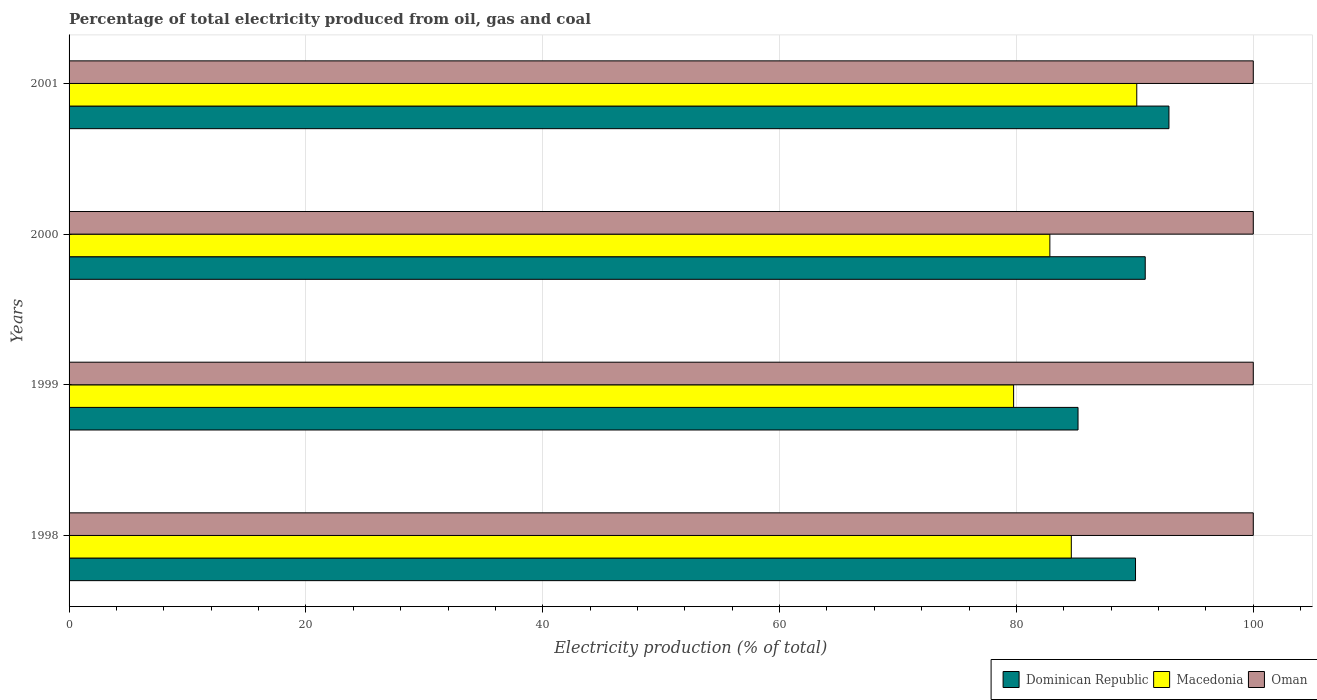Are the number of bars per tick equal to the number of legend labels?
Your answer should be compact. Yes. How many bars are there on the 2nd tick from the top?
Give a very brief answer. 3. How many bars are there on the 1st tick from the bottom?
Provide a succinct answer. 3. In how many cases, is the number of bars for a given year not equal to the number of legend labels?
Provide a short and direct response. 0. Across all years, what is the maximum electricity production in in Macedonia?
Offer a very short reply. 90.16. Across all years, what is the minimum electricity production in in Macedonia?
Your answer should be very brief. 79.76. What is the difference between the electricity production in in Dominican Republic in 1999 and that in 2000?
Provide a short and direct response. -5.68. What is the difference between the electricity production in in Dominican Republic in 2000 and the electricity production in in Macedonia in 1998?
Give a very brief answer. 6.24. What is the average electricity production in in Dominican Republic per year?
Give a very brief answer. 89.75. In the year 1999, what is the difference between the electricity production in in Dominican Republic and electricity production in in Macedonia?
Your answer should be compact. 5.44. What is the ratio of the electricity production in in Macedonia in 1998 to that in 1999?
Provide a succinct answer. 1.06. Is the difference between the electricity production in in Dominican Republic in 2000 and 2001 greater than the difference between the electricity production in in Macedonia in 2000 and 2001?
Offer a very short reply. Yes. What is the difference between the highest and the second highest electricity production in in Dominican Republic?
Your response must be concise. 2. What is the difference between the highest and the lowest electricity production in in Macedonia?
Keep it short and to the point. 10.4. Is the sum of the electricity production in in Macedonia in 1998 and 2001 greater than the maximum electricity production in in Dominican Republic across all years?
Ensure brevity in your answer.  Yes. What does the 1st bar from the top in 1999 represents?
Give a very brief answer. Oman. What does the 1st bar from the bottom in 1998 represents?
Your answer should be compact. Dominican Republic. Is it the case that in every year, the sum of the electricity production in in Dominican Republic and electricity production in in Macedonia is greater than the electricity production in in Oman?
Your answer should be compact. Yes. Are all the bars in the graph horizontal?
Give a very brief answer. Yes. What is the difference between two consecutive major ticks on the X-axis?
Provide a succinct answer. 20. Are the values on the major ticks of X-axis written in scientific E-notation?
Keep it short and to the point. No. How are the legend labels stacked?
Provide a succinct answer. Horizontal. What is the title of the graph?
Offer a terse response. Percentage of total electricity produced from oil, gas and coal. What is the label or title of the X-axis?
Provide a succinct answer. Electricity production (% of total). What is the Electricity production (% of total) of Dominican Republic in 1998?
Keep it short and to the point. 90.06. What is the Electricity production (% of total) in Macedonia in 1998?
Your answer should be compact. 84.63. What is the Electricity production (% of total) of Dominican Republic in 1999?
Your answer should be compact. 85.2. What is the Electricity production (% of total) in Macedonia in 1999?
Provide a short and direct response. 79.76. What is the Electricity production (% of total) of Oman in 1999?
Your response must be concise. 100. What is the Electricity production (% of total) of Dominican Republic in 2000?
Your answer should be very brief. 90.88. What is the Electricity production (% of total) of Macedonia in 2000?
Ensure brevity in your answer.  82.82. What is the Electricity production (% of total) of Dominican Republic in 2001?
Make the answer very short. 92.88. What is the Electricity production (% of total) in Macedonia in 2001?
Your answer should be very brief. 90.16. What is the Electricity production (% of total) of Oman in 2001?
Keep it short and to the point. 100. Across all years, what is the maximum Electricity production (% of total) of Dominican Republic?
Your answer should be very brief. 92.88. Across all years, what is the maximum Electricity production (% of total) of Macedonia?
Provide a short and direct response. 90.16. Across all years, what is the minimum Electricity production (% of total) in Dominican Republic?
Give a very brief answer. 85.2. Across all years, what is the minimum Electricity production (% of total) in Macedonia?
Your answer should be compact. 79.76. Across all years, what is the minimum Electricity production (% of total) in Oman?
Provide a succinct answer. 100. What is the total Electricity production (% of total) in Dominican Republic in the graph?
Keep it short and to the point. 359.01. What is the total Electricity production (% of total) of Macedonia in the graph?
Your response must be concise. 337.38. What is the total Electricity production (% of total) in Oman in the graph?
Ensure brevity in your answer.  400. What is the difference between the Electricity production (% of total) of Dominican Republic in 1998 and that in 1999?
Make the answer very short. 4.86. What is the difference between the Electricity production (% of total) in Macedonia in 1998 and that in 1999?
Offer a terse response. 4.87. What is the difference between the Electricity production (% of total) of Oman in 1998 and that in 1999?
Your answer should be compact. 0. What is the difference between the Electricity production (% of total) in Dominican Republic in 1998 and that in 2000?
Offer a terse response. -0.82. What is the difference between the Electricity production (% of total) of Macedonia in 1998 and that in 2000?
Ensure brevity in your answer.  1.81. What is the difference between the Electricity production (% of total) in Oman in 1998 and that in 2000?
Your answer should be very brief. 0. What is the difference between the Electricity production (% of total) in Dominican Republic in 1998 and that in 2001?
Give a very brief answer. -2.82. What is the difference between the Electricity production (% of total) in Macedonia in 1998 and that in 2001?
Offer a terse response. -5.53. What is the difference between the Electricity production (% of total) of Dominican Republic in 1999 and that in 2000?
Give a very brief answer. -5.68. What is the difference between the Electricity production (% of total) in Macedonia in 1999 and that in 2000?
Your response must be concise. -3.06. What is the difference between the Electricity production (% of total) in Oman in 1999 and that in 2000?
Ensure brevity in your answer.  0. What is the difference between the Electricity production (% of total) of Dominican Republic in 1999 and that in 2001?
Give a very brief answer. -7.68. What is the difference between the Electricity production (% of total) in Macedonia in 1999 and that in 2001?
Offer a terse response. -10.4. What is the difference between the Electricity production (% of total) in Oman in 1999 and that in 2001?
Provide a succinct answer. 0. What is the difference between the Electricity production (% of total) in Dominican Republic in 2000 and that in 2001?
Your answer should be compact. -2. What is the difference between the Electricity production (% of total) of Macedonia in 2000 and that in 2001?
Provide a short and direct response. -7.34. What is the difference between the Electricity production (% of total) in Dominican Republic in 1998 and the Electricity production (% of total) in Macedonia in 1999?
Make the answer very short. 10.29. What is the difference between the Electricity production (% of total) in Dominican Republic in 1998 and the Electricity production (% of total) in Oman in 1999?
Give a very brief answer. -9.94. What is the difference between the Electricity production (% of total) in Macedonia in 1998 and the Electricity production (% of total) in Oman in 1999?
Your response must be concise. -15.37. What is the difference between the Electricity production (% of total) of Dominican Republic in 1998 and the Electricity production (% of total) of Macedonia in 2000?
Offer a terse response. 7.23. What is the difference between the Electricity production (% of total) of Dominican Republic in 1998 and the Electricity production (% of total) of Oman in 2000?
Offer a terse response. -9.94. What is the difference between the Electricity production (% of total) of Macedonia in 1998 and the Electricity production (% of total) of Oman in 2000?
Offer a very short reply. -15.37. What is the difference between the Electricity production (% of total) of Dominican Republic in 1998 and the Electricity production (% of total) of Macedonia in 2001?
Your answer should be very brief. -0.1. What is the difference between the Electricity production (% of total) in Dominican Republic in 1998 and the Electricity production (% of total) in Oman in 2001?
Give a very brief answer. -9.94. What is the difference between the Electricity production (% of total) of Macedonia in 1998 and the Electricity production (% of total) of Oman in 2001?
Ensure brevity in your answer.  -15.37. What is the difference between the Electricity production (% of total) of Dominican Republic in 1999 and the Electricity production (% of total) of Macedonia in 2000?
Your answer should be very brief. 2.38. What is the difference between the Electricity production (% of total) of Dominican Republic in 1999 and the Electricity production (% of total) of Oman in 2000?
Your answer should be compact. -14.8. What is the difference between the Electricity production (% of total) in Macedonia in 1999 and the Electricity production (% of total) in Oman in 2000?
Provide a short and direct response. -20.24. What is the difference between the Electricity production (% of total) in Dominican Republic in 1999 and the Electricity production (% of total) in Macedonia in 2001?
Provide a succinct answer. -4.96. What is the difference between the Electricity production (% of total) of Dominican Republic in 1999 and the Electricity production (% of total) of Oman in 2001?
Ensure brevity in your answer.  -14.8. What is the difference between the Electricity production (% of total) of Macedonia in 1999 and the Electricity production (% of total) of Oman in 2001?
Your response must be concise. -20.24. What is the difference between the Electricity production (% of total) of Dominican Republic in 2000 and the Electricity production (% of total) of Macedonia in 2001?
Ensure brevity in your answer.  0.72. What is the difference between the Electricity production (% of total) in Dominican Republic in 2000 and the Electricity production (% of total) in Oman in 2001?
Keep it short and to the point. -9.12. What is the difference between the Electricity production (% of total) in Macedonia in 2000 and the Electricity production (% of total) in Oman in 2001?
Offer a very short reply. -17.18. What is the average Electricity production (% of total) in Dominican Republic per year?
Provide a succinct answer. 89.75. What is the average Electricity production (% of total) of Macedonia per year?
Offer a very short reply. 84.34. What is the average Electricity production (% of total) of Oman per year?
Offer a very short reply. 100. In the year 1998, what is the difference between the Electricity production (% of total) of Dominican Republic and Electricity production (% of total) of Macedonia?
Give a very brief answer. 5.42. In the year 1998, what is the difference between the Electricity production (% of total) of Dominican Republic and Electricity production (% of total) of Oman?
Give a very brief answer. -9.94. In the year 1998, what is the difference between the Electricity production (% of total) of Macedonia and Electricity production (% of total) of Oman?
Offer a very short reply. -15.37. In the year 1999, what is the difference between the Electricity production (% of total) of Dominican Republic and Electricity production (% of total) of Macedonia?
Provide a succinct answer. 5.44. In the year 1999, what is the difference between the Electricity production (% of total) in Dominican Republic and Electricity production (% of total) in Oman?
Provide a short and direct response. -14.8. In the year 1999, what is the difference between the Electricity production (% of total) in Macedonia and Electricity production (% of total) in Oman?
Offer a very short reply. -20.24. In the year 2000, what is the difference between the Electricity production (% of total) of Dominican Republic and Electricity production (% of total) of Macedonia?
Make the answer very short. 8.05. In the year 2000, what is the difference between the Electricity production (% of total) of Dominican Republic and Electricity production (% of total) of Oman?
Provide a short and direct response. -9.12. In the year 2000, what is the difference between the Electricity production (% of total) in Macedonia and Electricity production (% of total) in Oman?
Your answer should be very brief. -17.18. In the year 2001, what is the difference between the Electricity production (% of total) in Dominican Republic and Electricity production (% of total) in Macedonia?
Your answer should be compact. 2.72. In the year 2001, what is the difference between the Electricity production (% of total) in Dominican Republic and Electricity production (% of total) in Oman?
Offer a very short reply. -7.12. In the year 2001, what is the difference between the Electricity production (% of total) of Macedonia and Electricity production (% of total) of Oman?
Give a very brief answer. -9.84. What is the ratio of the Electricity production (% of total) in Dominican Republic in 1998 to that in 1999?
Your response must be concise. 1.06. What is the ratio of the Electricity production (% of total) of Macedonia in 1998 to that in 1999?
Keep it short and to the point. 1.06. What is the ratio of the Electricity production (% of total) of Oman in 1998 to that in 1999?
Make the answer very short. 1. What is the ratio of the Electricity production (% of total) of Dominican Republic in 1998 to that in 2000?
Your response must be concise. 0.99. What is the ratio of the Electricity production (% of total) in Macedonia in 1998 to that in 2000?
Your response must be concise. 1.02. What is the ratio of the Electricity production (% of total) in Dominican Republic in 1998 to that in 2001?
Your answer should be compact. 0.97. What is the ratio of the Electricity production (% of total) of Macedonia in 1998 to that in 2001?
Give a very brief answer. 0.94. What is the ratio of the Electricity production (% of total) of Oman in 1998 to that in 2001?
Your response must be concise. 1. What is the ratio of the Electricity production (% of total) of Dominican Republic in 1999 to that in 2000?
Give a very brief answer. 0.94. What is the ratio of the Electricity production (% of total) of Dominican Republic in 1999 to that in 2001?
Your response must be concise. 0.92. What is the ratio of the Electricity production (% of total) in Macedonia in 1999 to that in 2001?
Make the answer very short. 0.88. What is the ratio of the Electricity production (% of total) in Dominican Republic in 2000 to that in 2001?
Offer a terse response. 0.98. What is the ratio of the Electricity production (% of total) in Macedonia in 2000 to that in 2001?
Keep it short and to the point. 0.92. What is the ratio of the Electricity production (% of total) in Oman in 2000 to that in 2001?
Ensure brevity in your answer.  1. What is the difference between the highest and the second highest Electricity production (% of total) of Dominican Republic?
Your answer should be very brief. 2. What is the difference between the highest and the second highest Electricity production (% of total) in Macedonia?
Your answer should be compact. 5.53. What is the difference between the highest and the lowest Electricity production (% of total) in Dominican Republic?
Offer a terse response. 7.68. What is the difference between the highest and the lowest Electricity production (% of total) in Macedonia?
Make the answer very short. 10.4. What is the difference between the highest and the lowest Electricity production (% of total) in Oman?
Your answer should be compact. 0. 